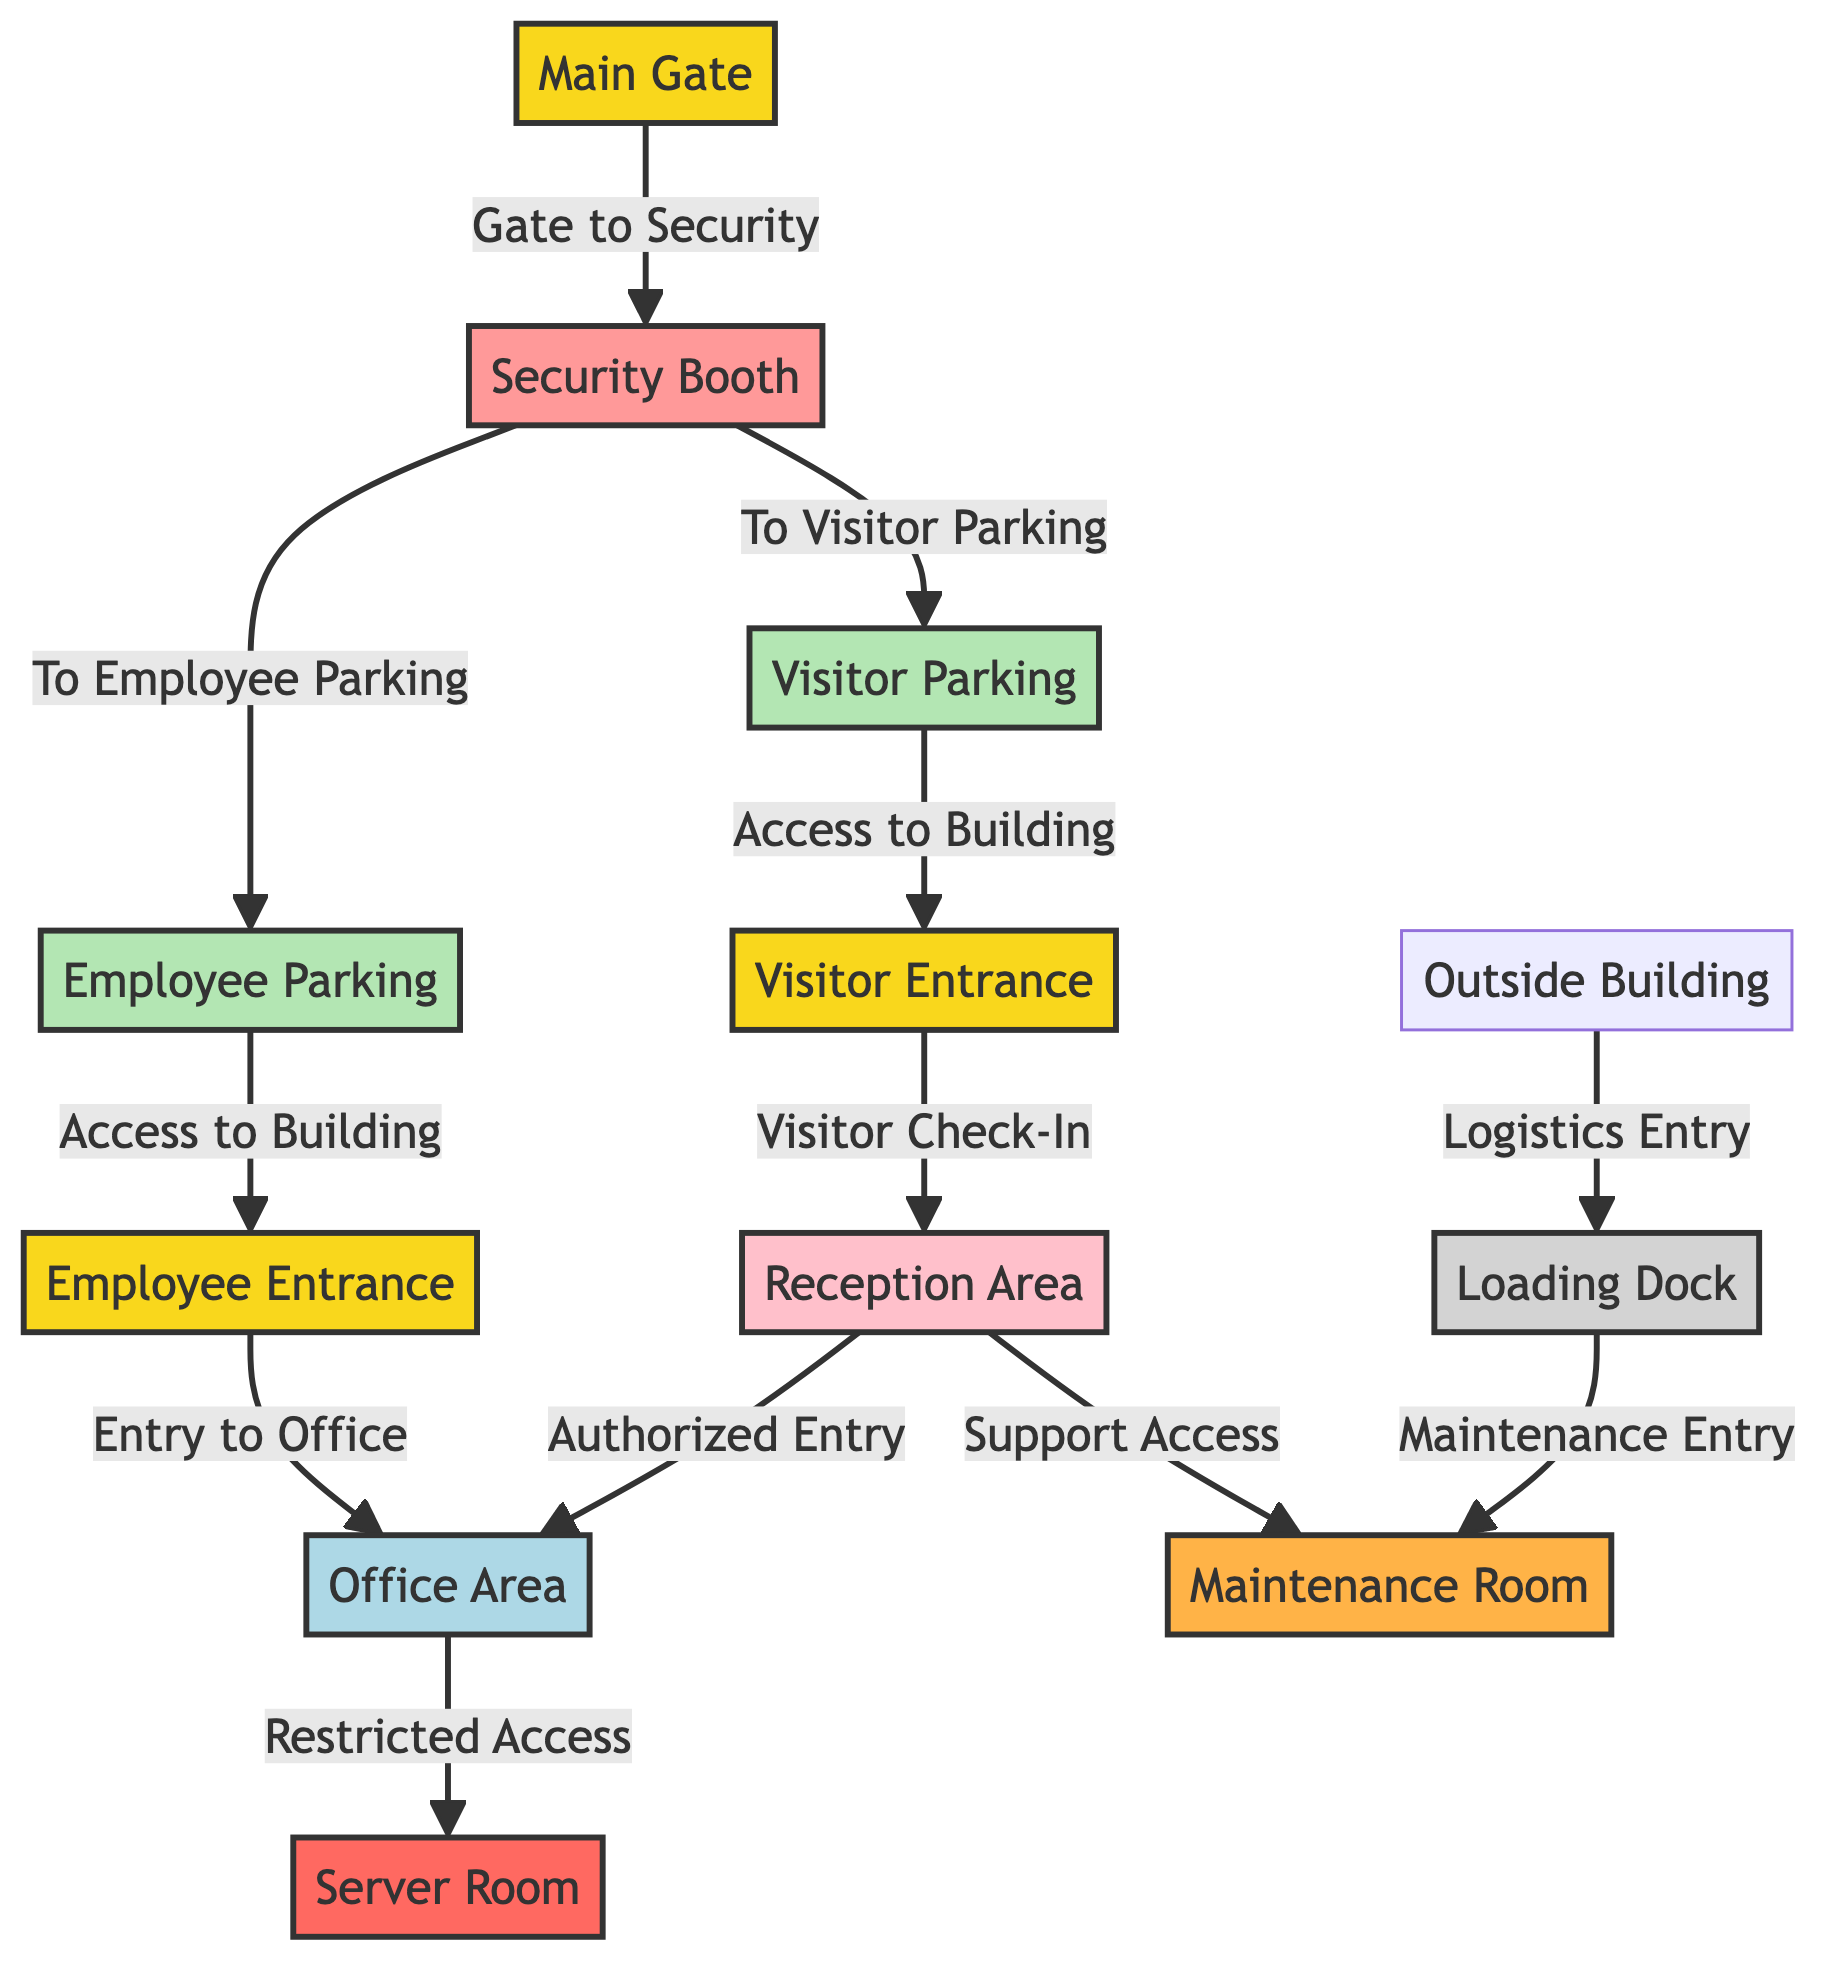What is the first entry point for visitors? The diagram shows the "Visitor Entrance" as the specific entry point designated for visitors, which is directly connected to the "Reception Area."
Answer: Visitor Entrance How many types of parking are indicated in the diagram? The diagram identifies two types of parking: "Employee Parking" and "Visitor Parking," as explicitly labeled nodes.
Answer: 2 What connects the main gate to the security booth? The "Main Gate" leads directly to the "Security Booth," indicating the flow of entry from the external building into the secured area.
Answer: Gate to Security Which area provides authorized entry to the office area? The "Reception Area" connects to the "Office Area," allowing only authorized visitors who check-in to gain access to the office.
Answer: Reception Area Which area is designated as restricted access? The "Server Room" is identified in the diagram as having restricted access, as indicated by its connection from the "Office Area."
Answer: Server Room From the visitor parking, what is the next point of entry into the building? Following the visitor parking in the diagram, the path leads directly to the "Visitor Entrance," indicating it as the next point of entry.
Answer: Visitor Entrance How do employees access the building from their parking area? Employees use the "Employee Entrance" to access the building after parking in the "Employee Parking," reflecting the designated flow.
Answer: Employee Entrance What room supports maintenance activities as shown in the diagram? The "Maintenance Room" is specified as the area that provides support access, connecting to both the "Reception Area" and "Loading Dock."
Answer: Maintenance Room Which node represents the main logistics entry point? The "Loading Dock" is indicated in the diagram as the main entry point for logistics, as it is accessed from the outside building.
Answer: Loading Dock 